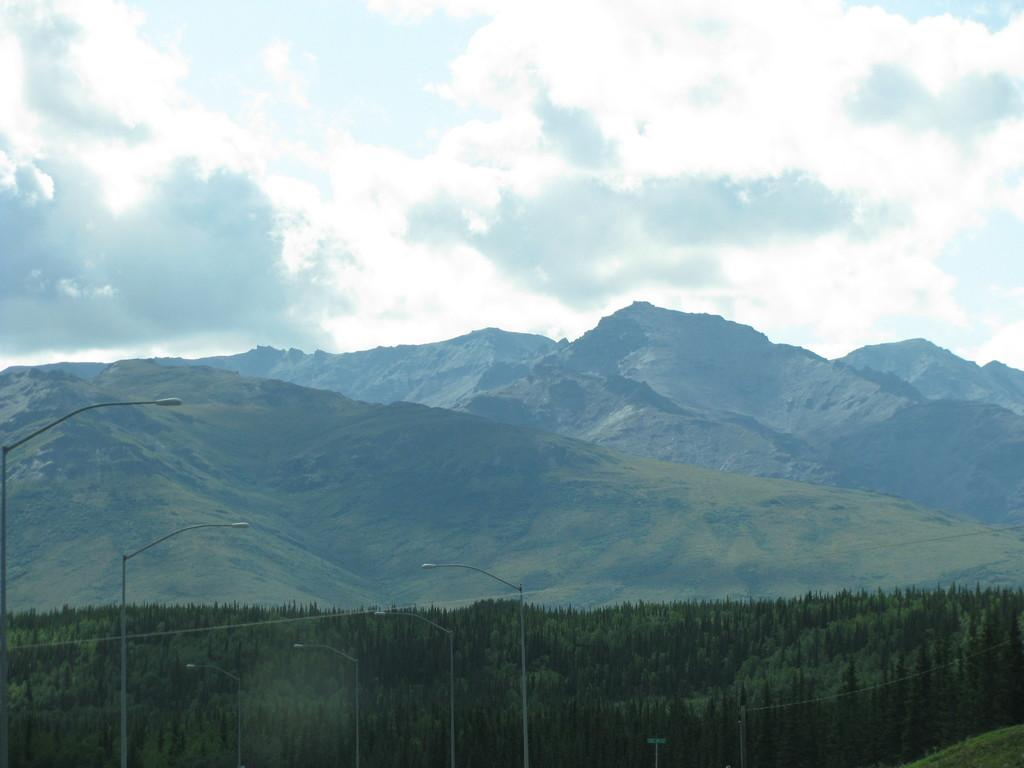What type of scenery is shown in the image? The image displays a beautiful view of nature. What structures can be seen in the front of the image? There are big street poles in the front of the image. What type of vegetation is visible in the image? There are many trees visible in the image. What geographical features are present in the background of the image? Huge mountains are present in the background of the image. What type of wren can be seen perched on the alarm in the image? There is no wren or alarm present in the image. Is there a notebook visible on the ground in the image? There is no notebook visible in the image. 